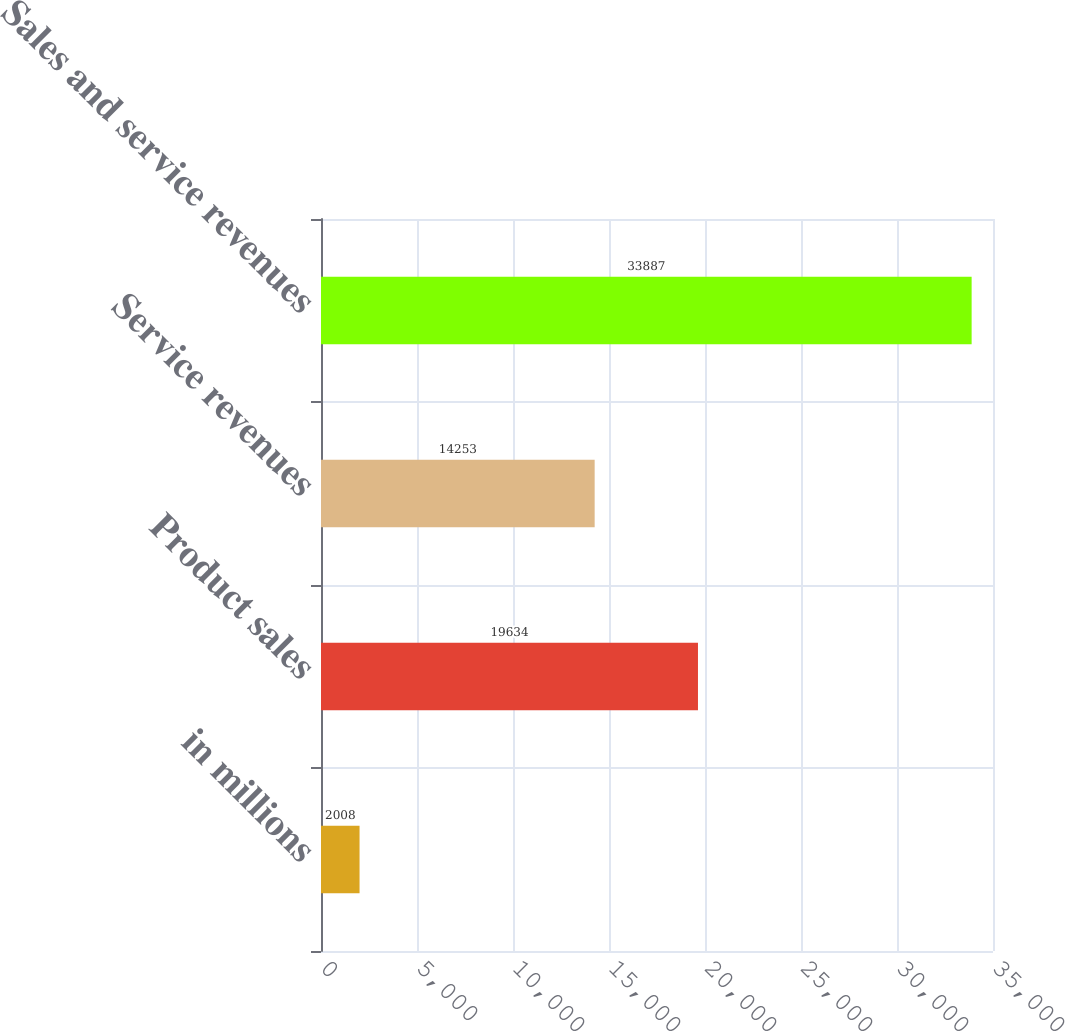Convert chart. <chart><loc_0><loc_0><loc_500><loc_500><bar_chart><fcel>in millions<fcel>Product sales<fcel>Service revenues<fcel>Sales and service revenues<nl><fcel>2008<fcel>19634<fcel>14253<fcel>33887<nl></chart> 